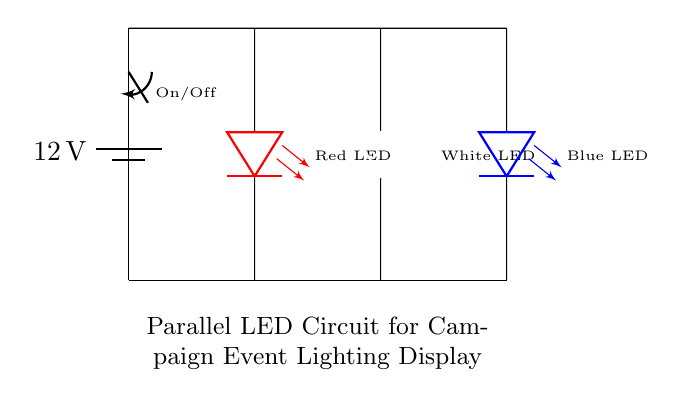What is the voltage of this circuit? The power supply provides a voltage of 12 volts, which is clearly indicated in the circuit diagram next to the battery symbol.
Answer: 12 volts How many LEDs are in the circuit? The circuit shows three distinct LED components: a red LED, a white LED, and a blue LED, making a total of three LEDs.
Answer: Three LEDs What type of circuit is this? The circuit features multiple branches connecting to a common voltage source, which is characteristic of a parallel circuit.
Answer: Parallel circuit What is the function of the switch in this circuit? The switch allows the user to turn the circuit on or off, controlling the flow of electricity to the LEDs based on the open or closed position of the switch.
Answer: On/Off control What color is the LED on the left? The LED on the left side of the circuit diagram is specified to be a red LED, as indicated by the label next to the LED symbol.
Answer: Red If one LED fails, will the others still light up? In a parallel circuit configuration, if one LED fails, the remaining LEDs will still operate because they are each connected independently to the voltage source.
Answer: Yes What happens if the switch is open? If the switch is open, it breaks the circuit continuity, preventing any current from flowing, and as a result, none of the LEDs will light up.
Answer: No lights 